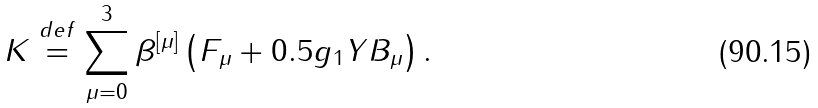Convert formula to latex. <formula><loc_0><loc_0><loc_500><loc_500>\ \ K \stackrel { d e f } { = } \sum _ { \mu = 0 } ^ { 3 } \beta ^ { \left [ \mu \right ] } \left ( F _ { \mu } + 0 . 5 g _ { 1 } Y B _ { \mu } \right ) .</formula> 